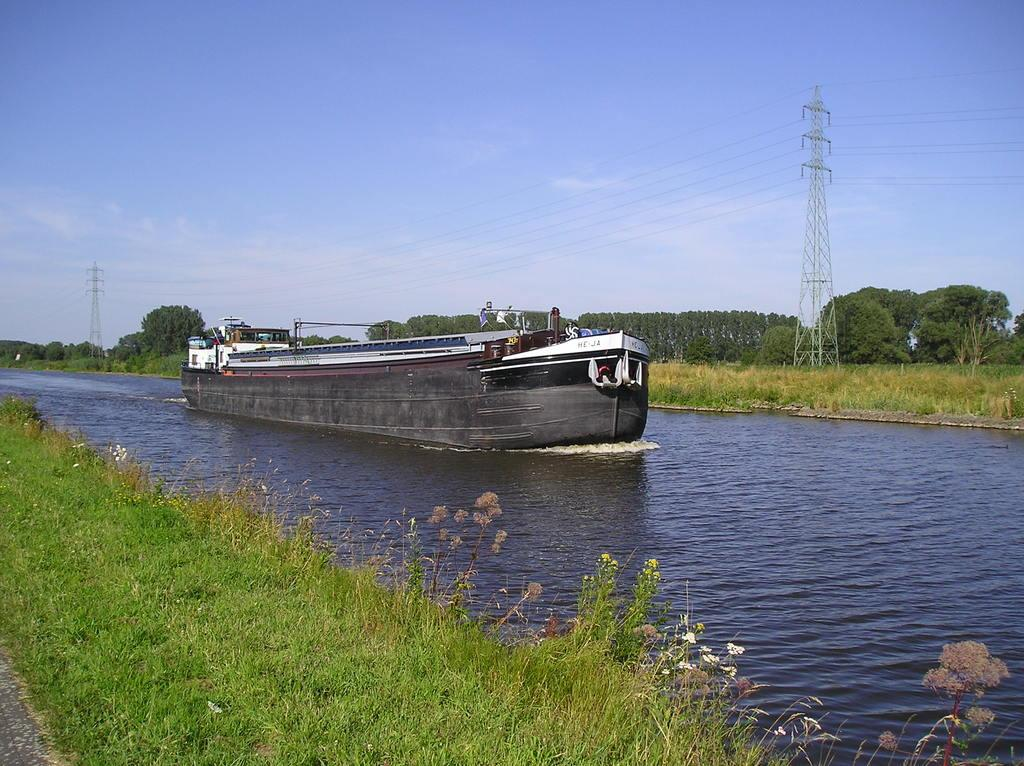What is on the water in the image? There is a boat on the water in the image. What type of vegetation can be seen in the image? There is grass visible in the image. What can be seen in the background of the image? There are trees, towers, and the sky visible in the background of the image. What type of soup is being served in the boat in the image? There is no soup present in the image; it features a boat on the water with no indication of food or drink. 